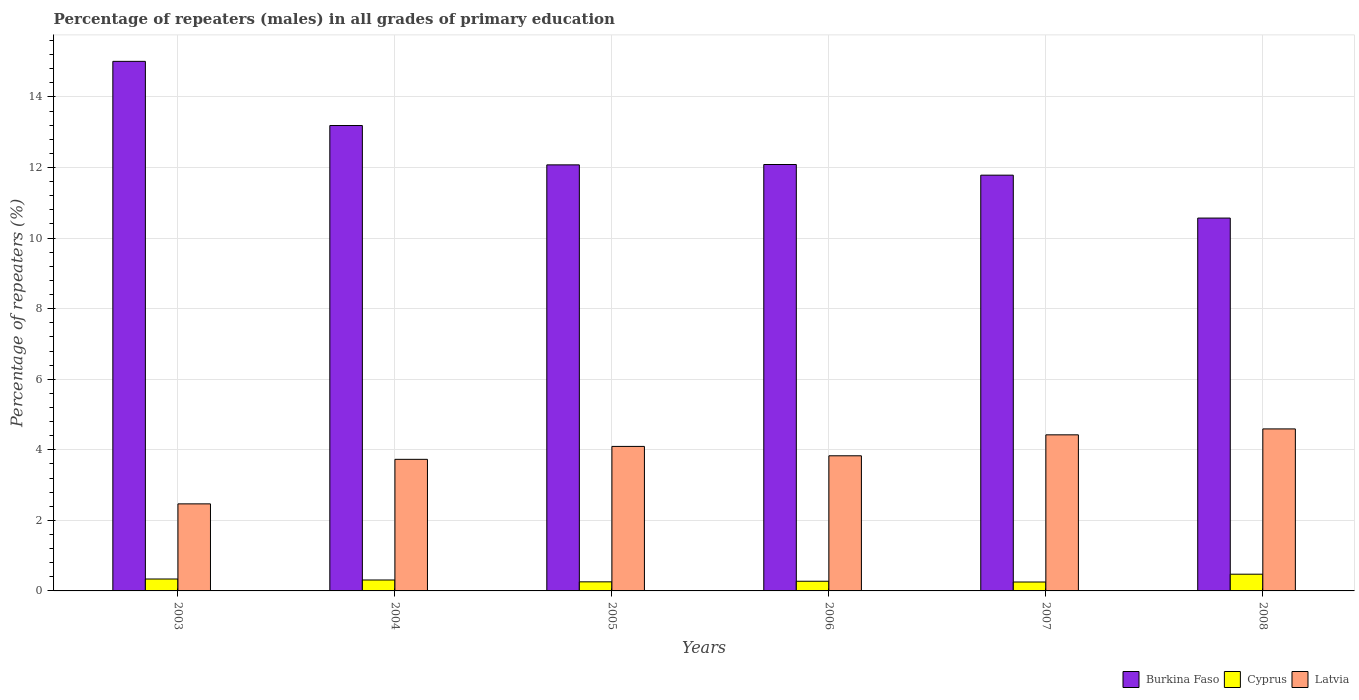How many bars are there on the 6th tick from the left?
Make the answer very short. 3. What is the label of the 2nd group of bars from the left?
Your answer should be compact. 2004. What is the percentage of repeaters (males) in Cyprus in 2005?
Offer a terse response. 0.26. Across all years, what is the maximum percentage of repeaters (males) in Latvia?
Provide a short and direct response. 4.59. Across all years, what is the minimum percentage of repeaters (males) in Cyprus?
Make the answer very short. 0.25. In which year was the percentage of repeaters (males) in Cyprus minimum?
Provide a succinct answer. 2007. What is the total percentage of repeaters (males) in Cyprus in the graph?
Your answer should be very brief. 1.91. What is the difference between the percentage of repeaters (males) in Latvia in 2005 and that in 2006?
Your answer should be very brief. 0.27. What is the difference between the percentage of repeaters (males) in Latvia in 2007 and the percentage of repeaters (males) in Cyprus in 2006?
Keep it short and to the point. 4.15. What is the average percentage of repeaters (males) in Burkina Faso per year?
Your response must be concise. 12.45. In the year 2006, what is the difference between the percentage of repeaters (males) in Latvia and percentage of repeaters (males) in Burkina Faso?
Your response must be concise. -8.26. In how many years, is the percentage of repeaters (males) in Latvia greater than 0.8 %?
Make the answer very short. 6. What is the ratio of the percentage of repeaters (males) in Cyprus in 2005 to that in 2007?
Ensure brevity in your answer.  1.02. Is the percentage of repeaters (males) in Latvia in 2005 less than that in 2007?
Offer a terse response. Yes. What is the difference between the highest and the second highest percentage of repeaters (males) in Burkina Faso?
Your response must be concise. 1.82. What is the difference between the highest and the lowest percentage of repeaters (males) in Latvia?
Provide a short and direct response. 2.12. In how many years, is the percentage of repeaters (males) in Cyprus greater than the average percentage of repeaters (males) in Cyprus taken over all years?
Offer a very short reply. 2. What does the 2nd bar from the left in 2004 represents?
Your answer should be very brief. Cyprus. What does the 3rd bar from the right in 2006 represents?
Ensure brevity in your answer.  Burkina Faso. Is it the case that in every year, the sum of the percentage of repeaters (males) in Cyprus and percentage of repeaters (males) in Latvia is greater than the percentage of repeaters (males) in Burkina Faso?
Your answer should be compact. No. How many bars are there?
Keep it short and to the point. 18. Are all the bars in the graph horizontal?
Make the answer very short. No. What is the difference between two consecutive major ticks on the Y-axis?
Give a very brief answer. 2. Does the graph contain any zero values?
Offer a terse response. No. Does the graph contain grids?
Provide a short and direct response. Yes. Where does the legend appear in the graph?
Your response must be concise. Bottom right. How many legend labels are there?
Your answer should be very brief. 3. What is the title of the graph?
Keep it short and to the point. Percentage of repeaters (males) in all grades of primary education. Does "Middle East & North Africa (all income levels)" appear as one of the legend labels in the graph?
Offer a very short reply. No. What is the label or title of the X-axis?
Give a very brief answer. Years. What is the label or title of the Y-axis?
Your response must be concise. Percentage of repeaters (%). What is the Percentage of repeaters (%) in Burkina Faso in 2003?
Offer a very short reply. 15.01. What is the Percentage of repeaters (%) of Cyprus in 2003?
Your answer should be very brief. 0.34. What is the Percentage of repeaters (%) of Latvia in 2003?
Keep it short and to the point. 2.47. What is the Percentage of repeaters (%) of Burkina Faso in 2004?
Your answer should be very brief. 13.19. What is the Percentage of repeaters (%) of Cyprus in 2004?
Keep it short and to the point. 0.31. What is the Percentage of repeaters (%) of Latvia in 2004?
Provide a short and direct response. 3.73. What is the Percentage of repeaters (%) of Burkina Faso in 2005?
Offer a very short reply. 12.08. What is the Percentage of repeaters (%) of Cyprus in 2005?
Give a very brief answer. 0.26. What is the Percentage of repeaters (%) in Latvia in 2005?
Offer a terse response. 4.1. What is the Percentage of repeaters (%) in Burkina Faso in 2006?
Give a very brief answer. 12.09. What is the Percentage of repeaters (%) of Cyprus in 2006?
Offer a terse response. 0.27. What is the Percentage of repeaters (%) of Latvia in 2006?
Offer a very short reply. 3.83. What is the Percentage of repeaters (%) of Burkina Faso in 2007?
Make the answer very short. 11.78. What is the Percentage of repeaters (%) of Cyprus in 2007?
Make the answer very short. 0.25. What is the Percentage of repeaters (%) of Latvia in 2007?
Provide a succinct answer. 4.42. What is the Percentage of repeaters (%) in Burkina Faso in 2008?
Make the answer very short. 10.57. What is the Percentage of repeaters (%) in Cyprus in 2008?
Give a very brief answer. 0.47. What is the Percentage of repeaters (%) in Latvia in 2008?
Offer a very short reply. 4.59. Across all years, what is the maximum Percentage of repeaters (%) in Burkina Faso?
Keep it short and to the point. 15.01. Across all years, what is the maximum Percentage of repeaters (%) in Cyprus?
Ensure brevity in your answer.  0.47. Across all years, what is the maximum Percentage of repeaters (%) in Latvia?
Your response must be concise. 4.59. Across all years, what is the minimum Percentage of repeaters (%) in Burkina Faso?
Provide a short and direct response. 10.57. Across all years, what is the minimum Percentage of repeaters (%) of Cyprus?
Give a very brief answer. 0.25. Across all years, what is the minimum Percentage of repeaters (%) in Latvia?
Ensure brevity in your answer.  2.47. What is the total Percentage of repeaters (%) of Burkina Faso in the graph?
Give a very brief answer. 74.71. What is the total Percentage of repeaters (%) in Cyprus in the graph?
Offer a very short reply. 1.91. What is the total Percentage of repeaters (%) in Latvia in the graph?
Ensure brevity in your answer.  23.14. What is the difference between the Percentage of repeaters (%) in Burkina Faso in 2003 and that in 2004?
Offer a very short reply. 1.82. What is the difference between the Percentage of repeaters (%) of Cyprus in 2003 and that in 2004?
Give a very brief answer. 0.03. What is the difference between the Percentage of repeaters (%) of Latvia in 2003 and that in 2004?
Ensure brevity in your answer.  -1.26. What is the difference between the Percentage of repeaters (%) in Burkina Faso in 2003 and that in 2005?
Ensure brevity in your answer.  2.93. What is the difference between the Percentage of repeaters (%) of Cyprus in 2003 and that in 2005?
Make the answer very short. 0.08. What is the difference between the Percentage of repeaters (%) of Latvia in 2003 and that in 2005?
Ensure brevity in your answer.  -1.63. What is the difference between the Percentage of repeaters (%) of Burkina Faso in 2003 and that in 2006?
Keep it short and to the point. 2.92. What is the difference between the Percentage of repeaters (%) in Cyprus in 2003 and that in 2006?
Make the answer very short. 0.06. What is the difference between the Percentage of repeaters (%) in Latvia in 2003 and that in 2006?
Keep it short and to the point. -1.36. What is the difference between the Percentage of repeaters (%) of Burkina Faso in 2003 and that in 2007?
Your response must be concise. 3.23. What is the difference between the Percentage of repeaters (%) in Cyprus in 2003 and that in 2007?
Keep it short and to the point. 0.09. What is the difference between the Percentage of repeaters (%) in Latvia in 2003 and that in 2007?
Give a very brief answer. -1.96. What is the difference between the Percentage of repeaters (%) of Burkina Faso in 2003 and that in 2008?
Your answer should be compact. 4.44. What is the difference between the Percentage of repeaters (%) in Cyprus in 2003 and that in 2008?
Your response must be concise. -0.14. What is the difference between the Percentage of repeaters (%) in Latvia in 2003 and that in 2008?
Offer a terse response. -2.12. What is the difference between the Percentage of repeaters (%) in Burkina Faso in 2004 and that in 2005?
Keep it short and to the point. 1.12. What is the difference between the Percentage of repeaters (%) in Cyprus in 2004 and that in 2005?
Your answer should be very brief. 0.05. What is the difference between the Percentage of repeaters (%) of Latvia in 2004 and that in 2005?
Your response must be concise. -0.37. What is the difference between the Percentage of repeaters (%) of Burkina Faso in 2004 and that in 2006?
Provide a succinct answer. 1.11. What is the difference between the Percentage of repeaters (%) in Cyprus in 2004 and that in 2006?
Make the answer very short. 0.04. What is the difference between the Percentage of repeaters (%) of Latvia in 2004 and that in 2006?
Offer a terse response. -0.1. What is the difference between the Percentage of repeaters (%) of Burkina Faso in 2004 and that in 2007?
Your response must be concise. 1.41. What is the difference between the Percentage of repeaters (%) in Cyprus in 2004 and that in 2007?
Your answer should be very brief. 0.06. What is the difference between the Percentage of repeaters (%) in Latvia in 2004 and that in 2007?
Ensure brevity in your answer.  -0.69. What is the difference between the Percentage of repeaters (%) in Burkina Faso in 2004 and that in 2008?
Provide a short and direct response. 2.62. What is the difference between the Percentage of repeaters (%) in Cyprus in 2004 and that in 2008?
Provide a succinct answer. -0.16. What is the difference between the Percentage of repeaters (%) in Latvia in 2004 and that in 2008?
Your response must be concise. -0.86. What is the difference between the Percentage of repeaters (%) of Burkina Faso in 2005 and that in 2006?
Provide a short and direct response. -0.01. What is the difference between the Percentage of repeaters (%) of Cyprus in 2005 and that in 2006?
Make the answer very short. -0.02. What is the difference between the Percentage of repeaters (%) in Latvia in 2005 and that in 2006?
Make the answer very short. 0.27. What is the difference between the Percentage of repeaters (%) of Burkina Faso in 2005 and that in 2007?
Make the answer very short. 0.29. What is the difference between the Percentage of repeaters (%) of Cyprus in 2005 and that in 2007?
Offer a very short reply. 0.01. What is the difference between the Percentage of repeaters (%) of Latvia in 2005 and that in 2007?
Provide a succinct answer. -0.33. What is the difference between the Percentage of repeaters (%) of Burkina Faso in 2005 and that in 2008?
Offer a very short reply. 1.51. What is the difference between the Percentage of repeaters (%) of Cyprus in 2005 and that in 2008?
Offer a terse response. -0.22. What is the difference between the Percentage of repeaters (%) of Latvia in 2005 and that in 2008?
Offer a terse response. -0.5. What is the difference between the Percentage of repeaters (%) of Burkina Faso in 2006 and that in 2007?
Your response must be concise. 0.3. What is the difference between the Percentage of repeaters (%) of Cyprus in 2006 and that in 2007?
Offer a very short reply. 0.02. What is the difference between the Percentage of repeaters (%) in Latvia in 2006 and that in 2007?
Your answer should be very brief. -0.59. What is the difference between the Percentage of repeaters (%) in Burkina Faso in 2006 and that in 2008?
Give a very brief answer. 1.52. What is the difference between the Percentage of repeaters (%) in Cyprus in 2006 and that in 2008?
Your answer should be compact. -0.2. What is the difference between the Percentage of repeaters (%) in Latvia in 2006 and that in 2008?
Make the answer very short. -0.76. What is the difference between the Percentage of repeaters (%) in Burkina Faso in 2007 and that in 2008?
Provide a short and direct response. 1.22. What is the difference between the Percentage of repeaters (%) of Cyprus in 2007 and that in 2008?
Make the answer very short. -0.22. What is the difference between the Percentage of repeaters (%) of Latvia in 2007 and that in 2008?
Offer a terse response. -0.17. What is the difference between the Percentage of repeaters (%) of Burkina Faso in 2003 and the Percentage of repeaters (%) of Cyprus in 2004?
Your response must be concise. 14.7. What is the difference between the Percentage of repeaters (%) in Burkina Faso in 2003 and the Percentage of repeaters (%) in Latvia in 2004?
Make the answer very short. 11.28. What is the difference between the Percentage of repeaters (%) of Cyprus in 2003 and the Percentage of repeaters (%) of Latvia in 2004?
Your answer should be compact. -3.39. What is the difference between the Percentage of repeaters (%) of Burkina Faso in 2003 and the Percentage of repeaters (%) of Cyprus in 2005?
Keep it short and to the point. 14.75. What is the difference between the Percentage of repeaters (%) of Burkina Faso in 2003 and the Percentage of repeaters (%) of Latvia in 2005?
Give a very brief answer. 10.91. What is the difference between the Percentage of repeaters (%) of Cyprus in 2003 and the Percentage of repeaters (%) of Latvia in 2005?
Offer a terse response. -3.76. What is the difference between the Percentage of repeaters (%) in Burkina Faso in 2003 and the Percentage of repeaters (%) in Cyprus in 2006?
Ensure brevity in your answer.  14.73. What is the difference between the Percentage of repeaters (%) in Burkina Faso in 2003 and the Percentage of repeaters (%) in Latvia in 2006?
Offer a terse response. 11.18. What is the difference between the Percentage of repeaters (%) of Cyprus in 2003 and the Percentage of repeaters (%) of Latvia in 2006?
Your answer should be compact. -3.49. What is the difference between the Percentage of repeaters (%) of Burkina Faso in 2003 and the Percentage of repeaters (%) of Cyprus in 2007?
Give a very brief answer. 14.76. What is the difference between the Percentage of repeaters (%) of Burkina Faso in 2003 and the Percentage of repeaters (%) of Latvia in 2007?
Make the answer very short. 10.59. What is the difference between the Percentage of repeaters (%) of Cyprus in 2003 and the Percentage of repeaters (%) of Latvia in 2007?
Provide a short and direct response. -4.09. What is the difference between the Percentage of repeaters (%) in Burkina Faso in 2003 and the Percentage of repeaters (%) in Cyprus in 2008?
Your answer should be very brief. 14.54. What is the difference between the Percentage of repeaters (%) of Burkina Faso in 2003 and the Percentage of repeaters (%) of Latvia in 2008?
Your answer should be compact. 10.42. What is the difference between the Percentage of repeaters (%) of Cyprus in 2003 and the Percentage of repeaters (%) of Latvia in 2008?
Offer a terse response. -4.25. What is the difference between the Percentage of repeaters (%) of Burkina Faso in 2004 and the Percentage of repeaters (%) of Cyprus in 2005?
Offer a terse response. 12.93. What is the difference between the Percentage of repeaters (%) of Burkina Faso in 2004 and the Percentage of repeaters (%) of Latvia in 2005?
Make the answer very short. 9.1. What is the difference between the Percentage of repeaters (%) of Cyprus in 2004 and the Percentage of repeaters (%) of Latvia in 2005?
Your answer should be compact. -3.79. What is the difference between the Percentage of repeaters (%) of Burkina Faso in 2004 and the Percentage of repeaters (%) of Cyprus in 2006?
Provide a succinct answer. 12.92. What is the difference between the Percentage of repeaters (%) in Burkina Faso in 2004 and the Percentage of repeaters (%) in Latvia in 2006?
Ensure brevity in your answer.  9.36. What is the difference between the Percentage of repeaters (%) in Cyprus in 2004 and the Percentage of repeaters (%) in Latvia in 2006?
Offer a very short reply. -3.52. What is the difference between the Percentage of repeaters (%) of Burkina Faso in 2004 and the Percentage of repeaters (%) of Cyprus in 2007?
Your response must be concise. 12.94. What is the difference between the Percentage of repeaters (%) of Burkina Faso in 2004 and the Percentage of repeaters (%) of Latvia in 2007?
Make the answer very short. 8.77. What is the difference between the Percentage of repeaters (%) of Cyprus in 2004 and the Percentage of repeaters (%) of Latvia in 2007?
Provide a short and direct response. -4.11. What is the difference between the Percentage of repeaters (%) in Burkina Faso in 2004 and the Percentage of repeaters (%) in Cyprus in 2008?
Your answer should be very brief. 12.72. What is the difference between the Percentage of repeaters (%) in Burkina Faso in 2004 and the Percentage of repeaters (%) in Latvia in 2008?
Provide a short and direct response. 8.6. What is the difference between the Percentage of repeaters (%) of Cyprus in 2004 and the Percentage of repeaters (%) of Latvia in 2008?
Make the answer very short. -4.28. What is the difference between the Percentage of repeaters (%) of Burkina Faso in 2005 and the Percentage of repeaters (%) of Cyprus in 2006?
Offer a terse response. 11.8. What is the difference between the Percentage of repeaters (%) of Burkina Faso in 2005 and the Percentage of repeaters (%) of Latvia in 2006?
Give a very brief answer. 8.25. What is the difference between the Percentage of repeaters (%) of Cyprus in 2005 and the Percentage of repeaters (%) of Latvia in 2006?
Give a very brief answer. -3.57. What is the difference between the Percentage of repeaters (%) in Burkina Faso in 2005 and the Percentage of repeaters (%) in Cyprus in 2007?
Make the answer very short. 11.82. What is the difference between the Percentage of repeaters (%) in Burkina Faso in 2005 and the Percentage of repeaters (%) in Latvia in 2007?
Ensure brevity in your answer.  7.65. What is the difference between the Percentage of repeaters (%) in Cyprus in 2005 and the Percentage of repeaters (%) in Latvia in 2007?
Your response must be concise. -4.17. What is the difference between the Percentage of repeaters (%) of Burkina Faso in 2005 and the Percentage of repeaters (%) of Cyprus in 2008?
Your answer should be very brief. 11.6. What is the difference between the Percentage of repeaters (%) of Burkina Faso in 2005 and the Percentage of repeaters (%) of Latvia in 2008?
Keep it short and to the point. 7.48. What is the difference between the Percentage of repeaters (%) of Cyprus in 2005 and the Percentage of repeaters (%) of Latvia in 2008?
Provide a succinct answer. -4.33. What is the difference between the Percentage of repeaters (%) of Burkina Faso in 2006 and the Percentage of repeaters (%) of Cyprus in 2007?
Give a very brief answer. 11.83. What is the difference between the Percentage of repeaters (%) in Burkina Faso in 2006 and the Percentage of repeaters (%) in Latvia in 2007?
Offer a very short reply. 7.66. What is the difference between the Percentage of repeaters (%) in Cyprus in 2006 and the Percentage of repeaters (%) in Latvia in 2007?
Your answer should be very brief. -4.15. What is the difference between the Percentage of repeaters (%) in Burkina Faso in 2006 and the Percentage of repeaters (%) in Cyprus in 2008?
Provide a short and direct response. 11.61. What is the difference between the Percentage of repeaters (%) of Burkina Faso in 2006 and the Percentage of repeaters (%) of Latvia in 2008?
Give a very brief answer. 7.49. What is the difference between the Percentage of repeaters (%) of Cyprus in 2006 and the Percentage of repeaters (%) of Latvia in 2008?
Offer a terse response. -4.32. What is the difference between the Percentage of repeaters (%) in Burkina Faso in 2007 and the Percentage of repeaters (%) in Cyprus in 2008?
Keep it short and to the point. 11.31. What is the difference between the Percentage of repeaters (%) of Burkina Faso in 2007 and the Percentage of repeaters (%) of Latvia in 2008?
Your answer should be very brief. 7.19. What is the difference between the Percentage of repeaters (%) in Cyprus in 2007 and the Percentage of repeaters (%) in Latvia in 2008?
Give a very brief answer. -4.34. What is the average Percentage of repeaters (%) of Burkina Faso per year?
Your response must be concise. 12.45. What is the average Percentage of repeaters (%) in Cyprus per year?
Your response must be concise. 0.32. What is the average Percentage of repeaters (%) in Latvia per year?
Offer a terse response. 3.86. In the year 2003, what is the difference between the Percentage of repeaters (%) in Burkina Faso and Percentage of repeaters (%) in Cyprus?
Your answer should be compact. 14.67. In the year 2003, what is the difference between the Percentage of repeaters (%) of Burkina Faso and Percentage of repeaters (%) of Latvia?
Your answer should be very brief. 12.54. In the year 2003, what is the difference between the Percentage of repeaters (%) of Cyprus and Percentage of repeaters (%) of Latvia?
Your answer should be compact. -2.13. In the year 2004, what is the difference between the Percentage of repeaters (%) in Burkina Faso and Percentage of repeaters (%) in Cyprus?
Your answer should be very brief. 12.88. In the year 2004, what is the difference between the Percentage of repeaters (%) in Burkina Faso and Percentage of repeaters (%) in Latvia?
Provide a succinct answer. 9.46. In the year 2004, what is the difference between the Percentage of repeaters (%) in Cyprus and Percentage of repeaters (%) in Latvia?
Your response must be concise. -3.42. In the year 2005, what is the difference between the Percentage of repeaters (%) in Burkina Faso and Percentage of repeaters (%) in Cyprus?
Ensure brevity in your answer.  11.82. In the year 2005, what is the difference between the Percentage of repeaters (%) in Burkina Faso and Percentage of repeaters (%) in Latvia?
Your answer should be very brief. 7.98. In the year 2005, what is the difference between the Percentage of repeaters (%) of Cyprus and Percentage of repeaters (%) of Latvia?
Make the answer very short. -3.84. In the year 2006, what is the difference between the Percentage of repeaters (%) in Burkina Faso and Percentage of repeaters (%) in Cyprus?
Provide a short and direct response. 11.81. In the year 2006, what is the difference between the Percentage of repeaters (%) of Burkina Faso and Percentage of repeaters (%) of Latvia?
Offer a terse response. 8.26. In the year 2006, what is the difference between the Percentage of repeaters (%) in Cyprus and Percentage of repeaters (%) in Latvia?
Make the answer very short. -3.56. In the year 2007, what is the difference between the Percentage of repeaters (%) of Burkina Faso and Percentage of repeaters (%) of Cyprus?
Make the answer very short. 11.53. In the year 2007, what is the difference between the Percentage of repeaters (%) in Burkina Faso and Percentage of repeaters (%) in Latvia?
Your answer should be very brief. 7.36. In the year 2007, what is the difference between the Percentage of repeaters (%) of Cyprus and Percentage of repeaters (%) of Latvia?
Your response must be concise. -4.17. In the year 2008, what is the difference between the Percentage of repeaters (%) in Burkina Faso and Percentage of repeaters (%) in Cyprus?
Your answer should be compact. 10.09. In the year 2008, what is the difference between the Percentage of repeaters (%) of Burkina Faso and Percentage of repeaters (%) of Latvia?
Make the answer very short. 5.98. In the year 2008, what is the difference between the Percentage of repeaters (%) of Cyprus and Percentage of repeaters (%) of Latvia?
Offer a terse response. -4.12. What is the ratio of the Percentage of repeaters (%) of Burkina Faso in 2003 to that in 2004?
Provide a succinct answer. 1.14. What is the ratio of the Percentage of repeaters (%) of Cyprus in 2003 to that in 2004?
Your answer should be compact. 1.09. What is the ratio of the Percentage of repeaters (%) of Latvia in 2003 to that in 2004?
Provide a succinct answer. 0.66. What is the ratio of the Percentage of repeaters (%) of Burkina Faso in 2003 to that in 2005?
Offer a very short reply. 1.24. What is the ratio of the Percentage of repeaters (%) in Cyprus in 2003 to that in 2005?
Offer a terse response. 1.31. What is the ratio of the Percentage of repeaters (%) in Latvia in 2003 to that in 2005?
Your response must be concise. 0.6. What is the ratio of the Percentage of repeaters (%) of Burkina Faso in 2003 to that in 2006?
Your answer should be compact. 1.24. What is the ratio of the Percentage of repeaters (%) in Cyprus in 2003 to that in 2006?
Provide a short and direct response. 1.23. What is the ratio of the Percentage of repeaters (%) of Latvia in 2003 to that in 2006?
Your response must be concise. 0.64. What is the ratio of the Percentage of repeaters (%) in Burkina Faso in 2003 to that in 2007?
Your answer should be very brief. 1.27. What is the ratio of the Percentage of repeaters (%) of Cyprus in 2003 to that in 2007?
Provide a succinct answer. 1.34. What is the ratio of the Percentage of repeaters (%) in Latvia in 2003 to that in 2007?
Ensure brevity in your answer.  0.56. What is the ratio of the Percentage of repeaters (%) of Burkina Faso in 2003 to that in 2008?
Keep it short and to the point. 1.42. What is the ratio of the Percentage of repeaters (%) of Cyprus in 2003 to that in 2008?
Give a very brief answer. 0.71. What is the ratio of the Percentage of repeaters (%) in Latvia in 2003 to that in 2008?
Provide a succinct answer. 0.54. What is the ratio of the Percentage of repeaters (%) of Burkina Faso in 2004 to that in 2005?
Offer a terse response. 1.09. What is the ratio of the Percentage of repeaters (%) in Cyprus in 2004 to that in 2005?
Your answer should be compact. 1.2. What is the ratio of the Percentage of repeaters (%) in Latvia in 2004 to that in 2005?
Make the answer very short. 0.91. What is the ratio of the Percentage of repeaters (%) of Burkina Faso in 2004 to that in 2006?
Keep it short and to the point. 1.09. What is the ratio of the Percentage of repeaters (%) in Cyprus in 2004 to that in 2006?
Your answer should be very brief. 1.13. What is the ratio of the Percentage of repeaters (%) of Latvia in 2004 to that in 2006?
Your answer should be very brief. 0.97. What is the ratio of the Percentage of repeaters (%) of Burkina Faso in 2004 to that in 2007?
Your answer should be compact. 1.12. What is the ratio of the Percentage of repeaters (%) of Cyprus in 2004 to that in 2007?
Give a very brief answer. 1.23. What is the ratio of the Percentage of repeaters (%) in Latvia in 2004 to that in 2007?
Offer a terse response. 0.84. What is the ratio of the Percentage of repeaters (%) in Burkina Faso in 2004 to that in 2008?
Give a very brief answer. 1.25. What is the ratio of the Percentage of repeaters (%) of Cyprus in 2004 to that in 2008?
Your answer should be compact. 0.65. What is the ratio of the Percentage of repeaters (%) in Latvia in 2004 to that in 2008?
Offer a terse response. 0.81. What is the ratio of the Percentage of repeaters (%) of Cyprus in 2005 to that in 2006?
Ensure brevity in your answer.  0.94. What is the ratio of the Percentage of repeaters (%) of Latvia in 2005 to that in 2006?
Keep it short and to the point. 1.07. What is the ratio of the Percentage of repeaters (%) in Burkina Faso in 2005 to that in 2007?
Provide a short and direct response. 1.02. What is the ratio of the Percentage of repeaters (%) in Cyprus in 2005 to that in 2007?
Keep it short and to the point. 1.02. What is the ratio of the Percentage of repeaters (%) of Latvia in 2005 to that in 2007?
Give a very brief answer. 0.93. What is the ratio of the Percentage of repeaters (%) in Burkina Faso in 2005 to that in 2008?
Your response must be concise. 1.14. What is the ratio of the Percentage of repeaters (%) of Cyprus in 2005 to that in 2008?
Give a very brief answer. 0.54. What is the ratio of the Percentage of repeaters (%) in Latvia in 2005 to that in 2008?
Give a very brief answer. 0.89. What is the ratio of the Percentage of repeaters (%) of Burkina Faso in 2006 to that in 2007?
Your answer should be very brief. 1.03. What is the ratio of the Percentage of repeaters (%) of Cyprus in 2006 to that in 2007?
Make the answer very short. 1.09. What is the ratio of the Percentage of repeaters (%) of Latvia in 2006 to that in 2007?
Provide a succinct answer. 0.87. What is the ratio of the Percentage of repeaters (%) of Burkina Faso in 2006 to that in 2008?
Give a very brief answer. 1.14. What is the ratio of the Percentage of repeaters (%) in Cyprus in 2006 to that in 2008?
Give a very brief answer. 0.58. What is the ratio of the Percentage of repeaters (%) of Latvia in 2006 to that in 2008?
Your response must be concise. 0.83. What is the ratio of the Percentage of repeaters (%) in Burkina Faso in 2007 to that in 2008?
Offer a very short reply. 1.12. What is the ratio of the Percentage of repeaters (%) of Cyprus in 2007 to that in 2008?
Your response must be concise. 0.53. What is the ratio of the Percentage of repeaters (%) in Latvia in 2007 to that in 2008?
Your response must be concise. 0.96. What is the difference between the highest and the second highest Percentage of repeaters (%) in Burkina Faso?
Provide a succinct answer. 1.82. What is the difference between the highest and the second highest Percentage of repeaters (%) in Cyprus?
Keep it short and to the point. 0.14. What is the difference between the highest and the second highest Percentage of repeaters (%) of Latvia?
Your answer should be very brief. 0.17. What is the difference between the highest and the lowest Percentage of repeaters (%) of Burkina Faso?
Your answer should be very brief. 4.44. What is the difference between the highest and the lowest Percentage of repeaters (%) of Cyprus?
Ensure brevity in your answer.  0.22. What is the difference between the highest and the lowest Percentage of repeaters (%) of Latvia?
Ensure brevity in your answer.  2.12. 